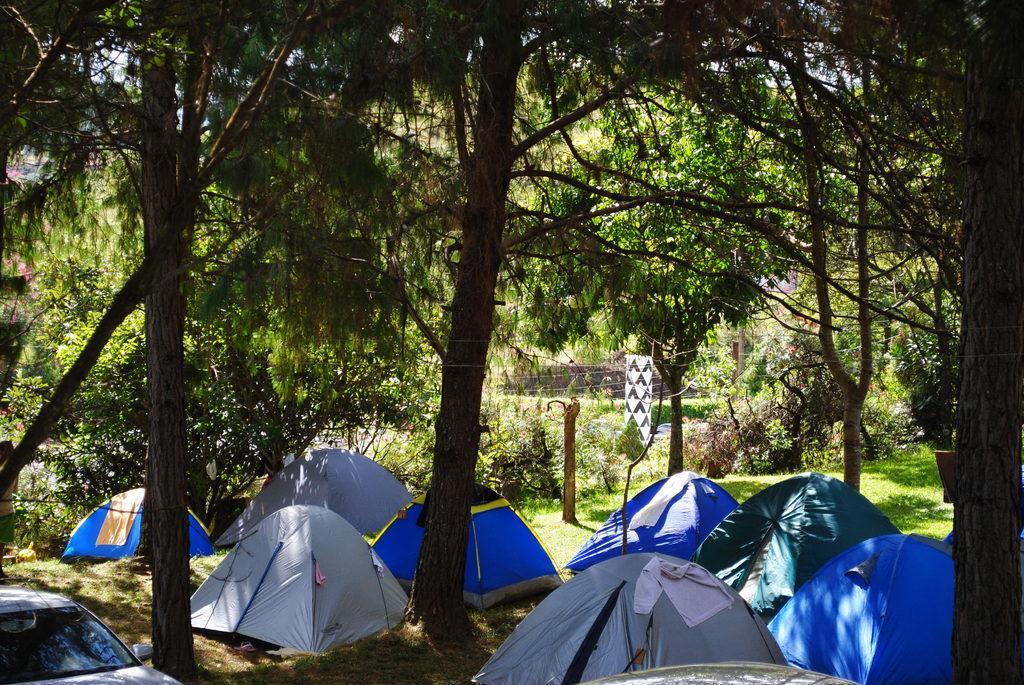Describe this image in one or two sentences. In this picture I can see few tents and I can see a car and few trees and looks like a building in the back and I can see sky. 